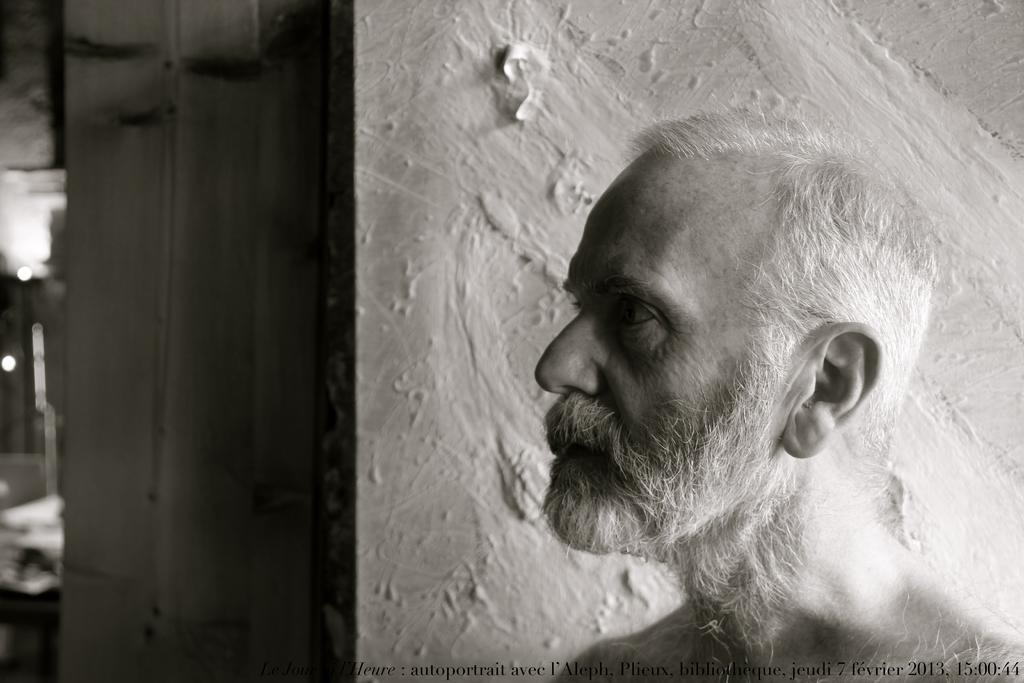Who is the main subject in the image? There is an old man in the image. Where is the old man located in the image? The old man is on the right side of the image. What is behind the old man in the image? There is a wall behind the old man. What type of square can be seen on the wall behind the old man? There is no square visible on the wall behind the old man in the image. 